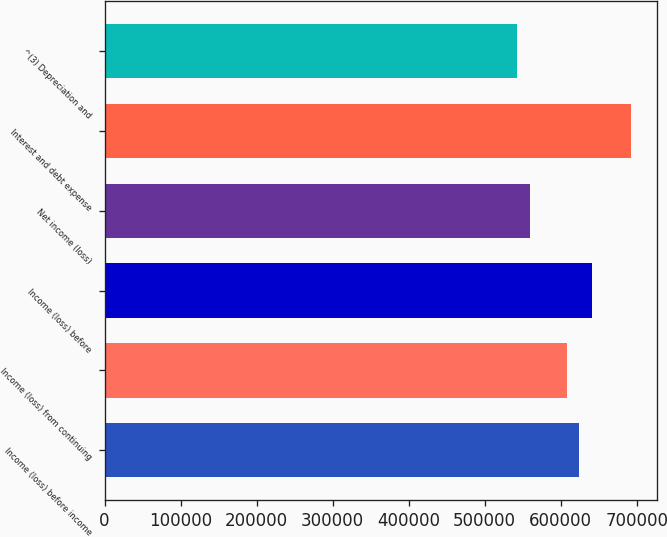Convert chart to OTSL. <chart><loc_0><loc_0><loc_500><loc_500><bar_chart><fcel>Income (loss) before income<fcel>Income (loss) from continuing<fcel>Income (loss) before<fcel>Net income (loss)<fcel>Interest and debt expense<fcel>^(3) Depreciation and<nl><fcel>623483<fcel>608485<fcel>640700<fcel>560140<fcel>692496<fcel>542515<nl></chart> 